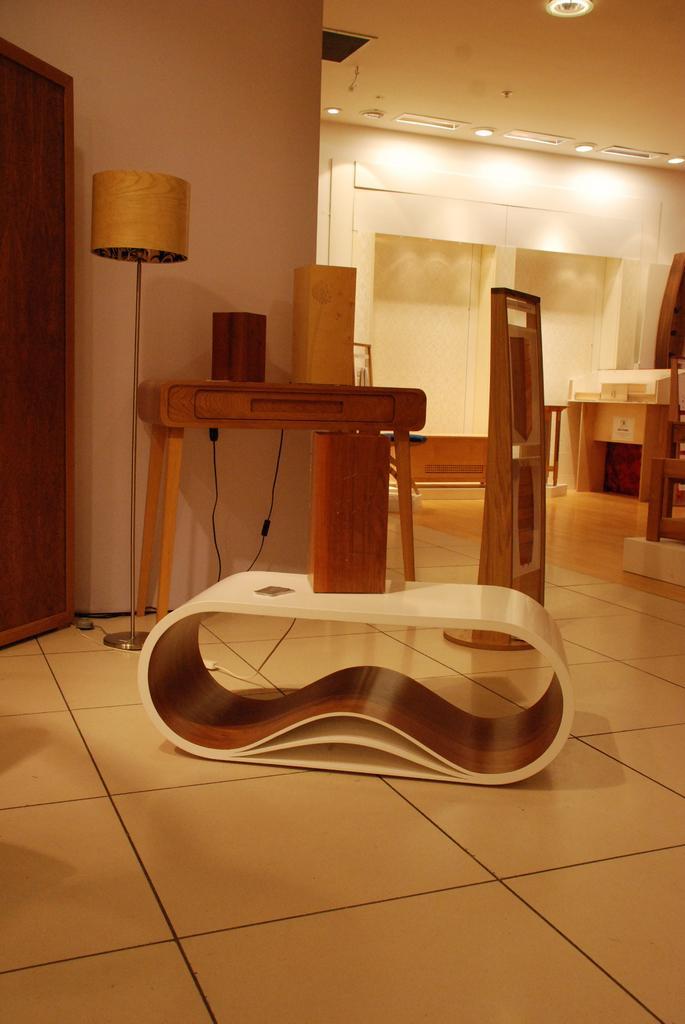Describe this image in one or two sentences. In this image we can see the inner view of a room. In the room there are electric lights, table lamp, wardrobe, side table, desk, cables and floor. 